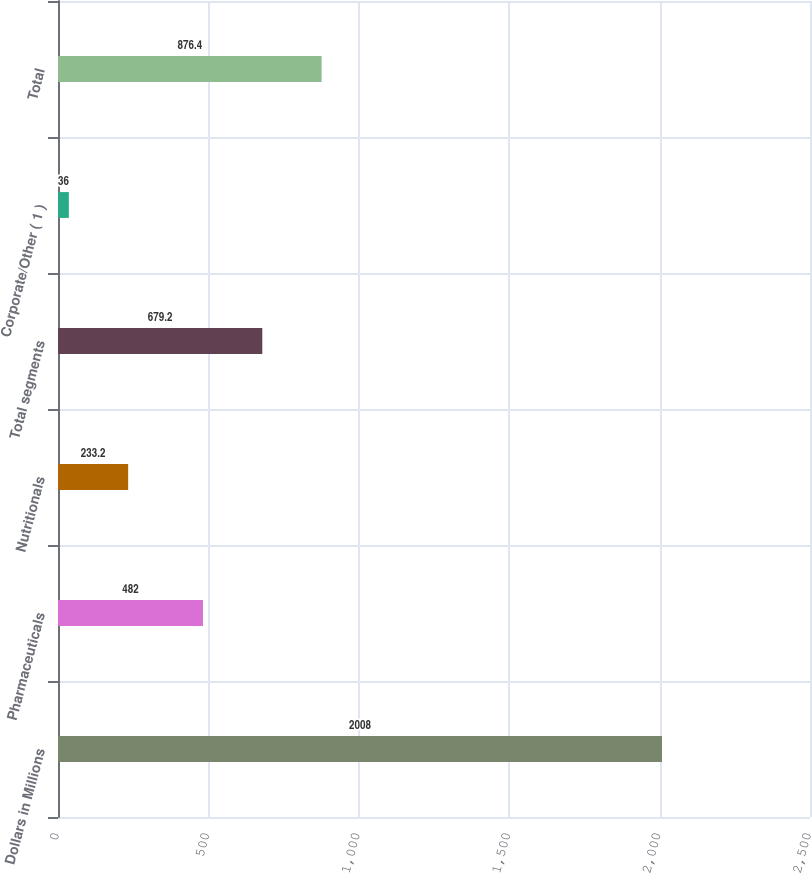<chart> <loc_0><loc_0><loc_500><loc_500><bar_chart><fcel>Dollars in Millions<fcel>Pharmaceuticals<fcel>Nutritionals<fcel>Total segments<fcel>Corporate/Other ( 1 )<fcel>Total<nl><fcel>2008<fcel>482<fcel>233.2<fcel>679.2<fcel>36<fcel>876.4<nl></chart> 